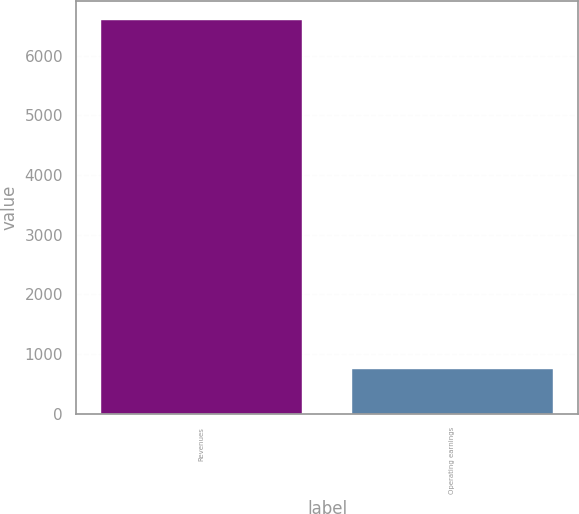<chart> <loc_0><loc_0><loc_500><loc_500><bar_chart><fcel>Revenues<fcel>Operating earnings<nl><fcel>6592<fcel>750<nl></chart> 